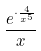Convert formula to latex. <formula><loc_0><loc_0><loc_500><loc_500>\frac { e ^ { \cdot \frac { 4 } { x ^ { 5 } } } } { x }</formula> 